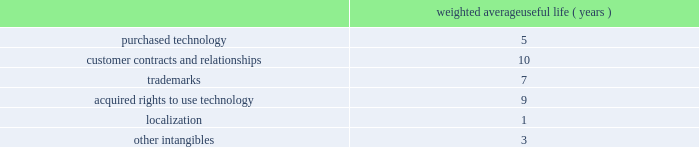Goodwill is assigned to one or more reporting segments on the date of acquisition .
We evaluate goodwill for impairment by comparing the fair value of each of our reporting segments to its carrying value , including the associated goodwill .
To determine the fair values , we use the market approach based on comparable publicly traded companies in similar lines of businesses and the income approach based on estimated discounted future cash flows .
Our cash flow assumptions consider historical and forecasted revenue , operating costs and other relevant factors .
We amortize intangible assets with finite lives over their estimated useful lives and review them for impairment whenever an impairment indicator exists .
We continually monitor events and changes in circumstances that could indicate carrying amounts of our long-lived assets , including our intangible assets may not be recoverable .
When such events or changes in circumstances occur , we assess recoverability by determining whether the carrying value of such assets will be recovered through the undiscounted expected future cash flows .
If the future undiscounted cash flows are less than the carrying amount of these assets , we recognize an impairment loss based on any excess of the carrying amount over the fair value of the assets .
We did not recognize any intangible asset impairment charges in fiscal 2012 , 2011 or 2010 .
Our intangible assets are amortized over their estimated useful lives of 1 to 13 years .
Amortization is based on the pattern in which the economic benefits of the intangible asset will be consumed .
The weighted average useful lives of our intangible assets was as follows : weighted average useful life ( years ) .
Software development costs capitalization of software development costs for software to be sold , leased , or otherwise marketed begins upon the establishment of technological feasibility , which is generally the completion of a working prototype that has been certified as having no critical bugs and is a release candidate .
Amortization begins once the software is ready for its intended use , generally based on the pattern in which the economic benefits will be consumed .
To date , software development costs incurred between completion of a working prototype and general availability of the related product have not been material .
Internal use software we capitalize costs associated with customized internal-use software systems that have reached the application development stage .
Such capitalized costs include external direct costs utilized in developing or obtaining the applications and payroll and payroll-related expenses for employees , who are directly associated with the development of the applications .
Capitalization of such costs begins when the preliminary project stage is complete and ceases at the point in which the project is substantially complete and is ready for its intended purpose .
Income taxes we use the asset and liability method of accounting for income taxes .
Under this method , income tax expense is recognized for the amount of taxes payable or refundable for the current year .
In addition , deferred tax assets and liabilities are recognized for expected future tax consequences of temporary differences between the financial reporting and tax bases of assets and liabilities , and for operating losses and tax credit carryforwards .
We record a valuation allowance to reduce deferred tax assets to an amount for which realization is more likely than not .
Table of contents adobe systems incorporated notes to consolidated financial statements ( continued ) .
How much longer in years is the life for customer contracts and relationships than for trademarks? 
Computations: (10 - 7)
Answer: 3.0. 